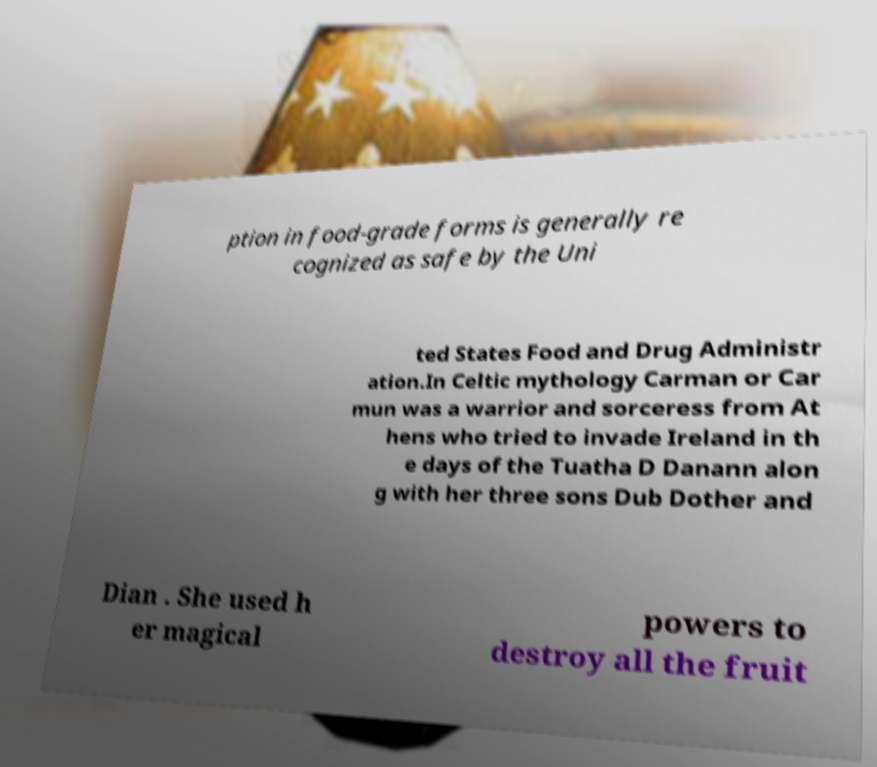Could you extract and type out the text from this image? ption in food-grade forms is generally re cognized as safe by the Uni ted States Food and Drug Administr ation.In Celtic mythology Carman or Car mun was a warrior and sorceress from At hens who tried to invade Ireland in th e days of the Tuatha D Danann alon g with her three sons Dub Dother and Dian . She used h er magical powers to destroy all the fruit 